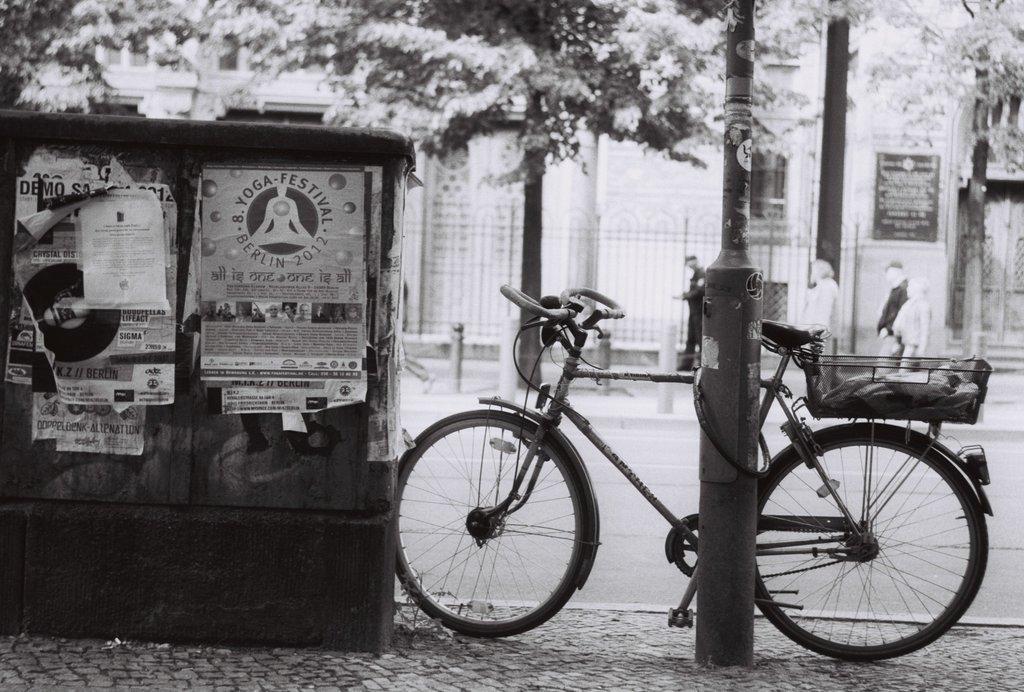Please provide a concise description of this image. This image is a black and white image. This image is taken outdoors. At the bottom of the image there is a sidewalk. In the background there are two buildings with walls, windows and doors. There is a board with a text on it. There is there is a fence and there is a pole. Three men are walking on the sidewalk. There are a few trees. In the middle of the image there is a road. A bicycle is parked on the sidewalk. There is a pole. There is a dustbin and there are a few posters with a text on the dustbin. 